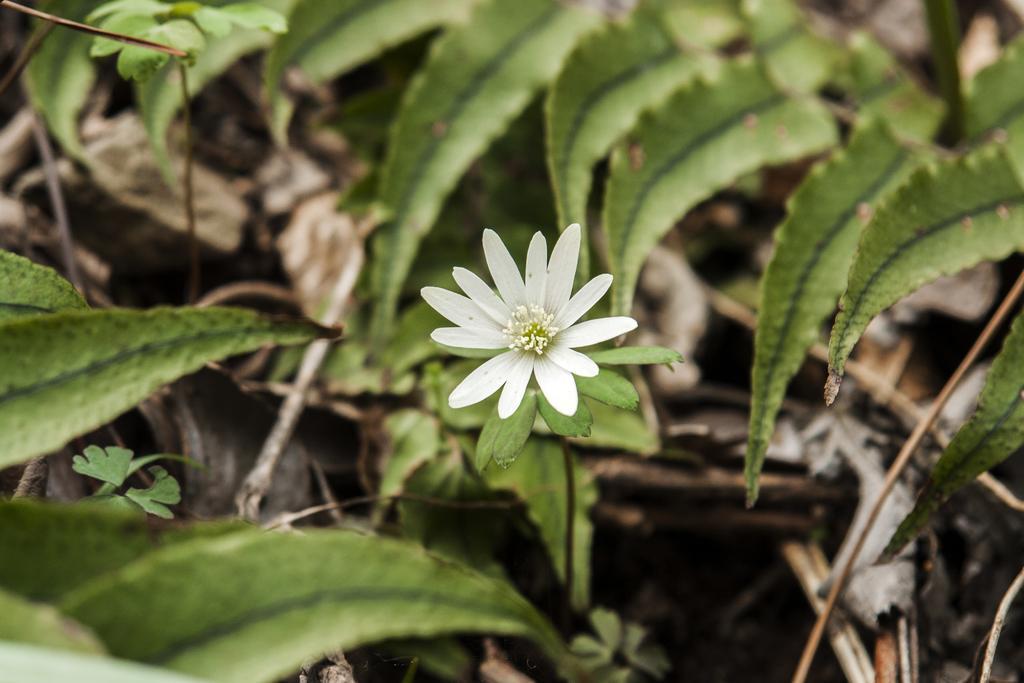In one or two sentences, can you explain what this image depicts? We can see white flower and green leaves. 